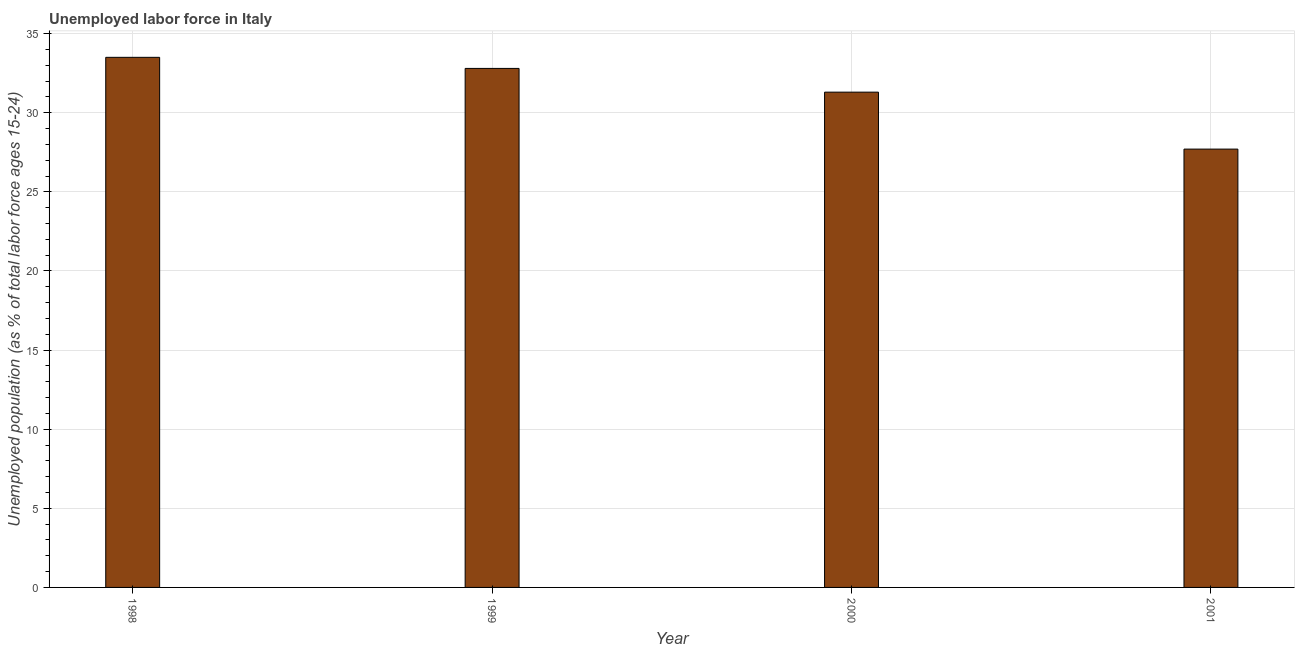Does the graph contain any zero values?
Ensure brevity in your answer.  No. What is the title of the graph?
Your response must be concise. Unemployed labor force in Italy. What is the label or title of the Y-axis?
Provide a short and direct response. Unemployed population (as % of total labor force ages 15-24). What is the total unemployed youth population in 2000?
Offer a very short reply. 31.3. Across all years, what is the maximum total unemployed youth population?
Your response must be concise. 33.5. Across all years, what is the minimum total unemployed youth population?
Your answer should be compact. 27.7. In which year was the total unemployed youth population maximum?
Make the answer very short. 1998. What is the sum of the total unemployed youth population?
Keep it short and to the point. 125.3. What is the difference between the total unemployed youth population in 1998 and 2001?
Make the answer very short. 5.8. What is the average total unemployed youth population per year?
Give a very brief answer. 31.32. What is the median total unemployed youth population?
Your answer should be very brief. 32.05. In how many years, is the total unemployed youth population greater than 3 %?
Your response must be concise. 4. Is the difference between the total unemployed youth population in 1999 and 2000 greater than the difference between any two years?
Give a very brief answer. No. Are the values on the major ticks of Y-axis written in scientific E-notation?
Your answer should be very brief. No. What is the Unemployed population (as % of total labor force ages 15-24) in 1998?
Ensure brevity in your answer.  33.5. What is the Unemployed population (as % of total labor force ages 15-24) of 1999?
Give a very brief answer. 32.8. What is the Unemployed population (as % of total labor force ages 15-24) of 2000?
Keep it short and to the point. 31.3. What is the Unemployed population (as % of total labor force ages 15-24) in 2001?
Offer a very short reply. 27.7. What is the difference between the Unemployed population (as % of total labor force ages 15-24) in 1998 and 2000?
Your answer should be compact. 2.2. What is the difference between the Unemployed population (as % of total labor force ages 15-24) in 1998 and 2001?
Your answer should be compact. 5.8. What is the difference between the Unemployed population (as % of total labor force ages 15-24) in 1999 and 2001?
Your answer should be very brief. 5.1. What is the ratio of the Unemployed population (as % of total labor force ages 15-24) in 1998 to that in 2000?
Provide a short and direct response. 1.07. What is the ratio of the Unemployed population (as % of total labor force ages 15-24) in 1998 to that in 2001?
Provide a succinct answer. 1.21. What is the ratio of the Unemployed population (as % of total labor force ages 15-24) in 1999 to that in 2000?
Provide a succinct answer. 1.05. What is the ratio of the Unemployed population (as % of total labor force ages 15-24) in 1999 to that in 2001?
Your answer should be compact. 1.18. What is the ratio of the Unemployed population (as % of total labor force ages 15-24) in 2000 to that in 2001?
Offer a very short reply. 1.13. 